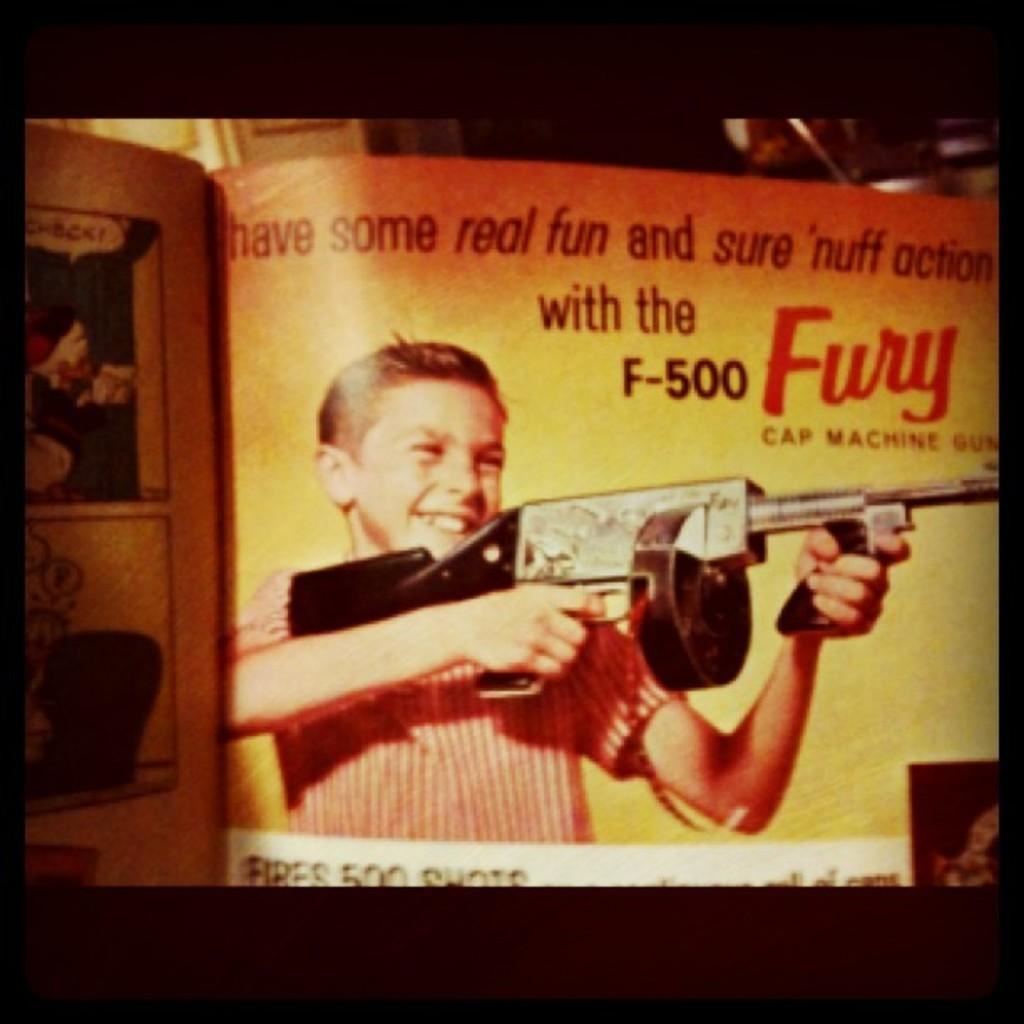What is the main subject of the image? The image resembles a book. What can be seen within the image? There is a depiction of a person in the image. What is present in the foreground of the image? There is text in the foreground of the image. What can be observed in the background of the image? There are objects in the background of the image. What type of grain is being harvested in the image? There is no depiction of grain or any harvesting activity in the image. Where is the nest located in the image? There is no nest present in the image. 